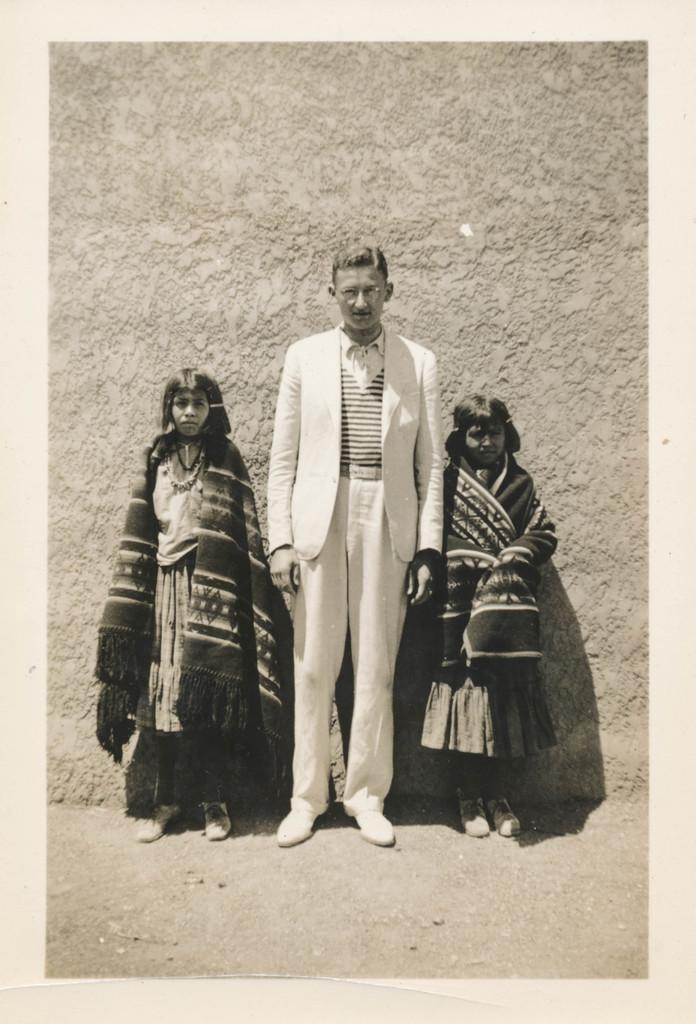How many people are in the image? There are three people in the image: a man and two girls. What are the positions of the people in the image? The man and the two girls are standing. What is the man wearing in the image? The man is wearing a coat and spectacles. What are the girls wearing in the image? The girls are wearing shawls. What can be seen in the background of the image? There is a wall visible in the background of the image. What is the condition of the grandmother in the image? There is no grandmother present in the image. Who is the expert in the image? The image does not depict any specific expertise or expert. 